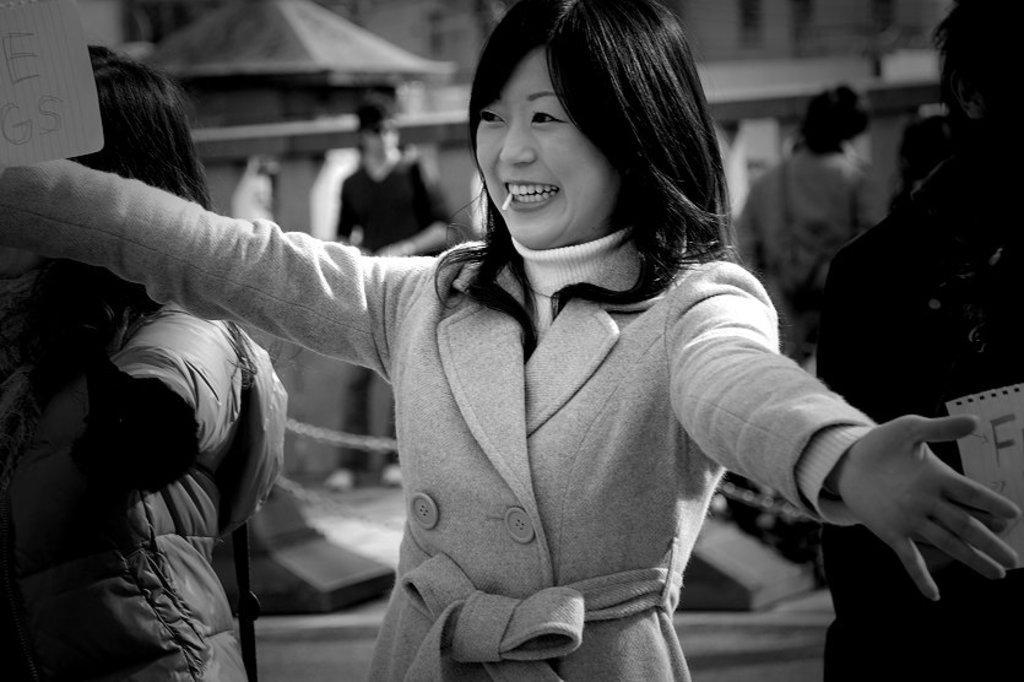How would you summarize this image in a sentence or two? It is a black and white image, there is a woman she is very happy and stretching her arms to give a hug and there are some other people around the woman, beside her there is another person she is wearing a jacket and the background of the woman is blur. 